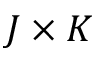Convert formula to latex. <formula><loc_0><loc_0><loc_500><loc_500>J \times K</formula> 